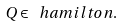<formula> <loc_0><loc_0><loc_500><loc_500>Q \in \ h a m i l t o n .</formula> 